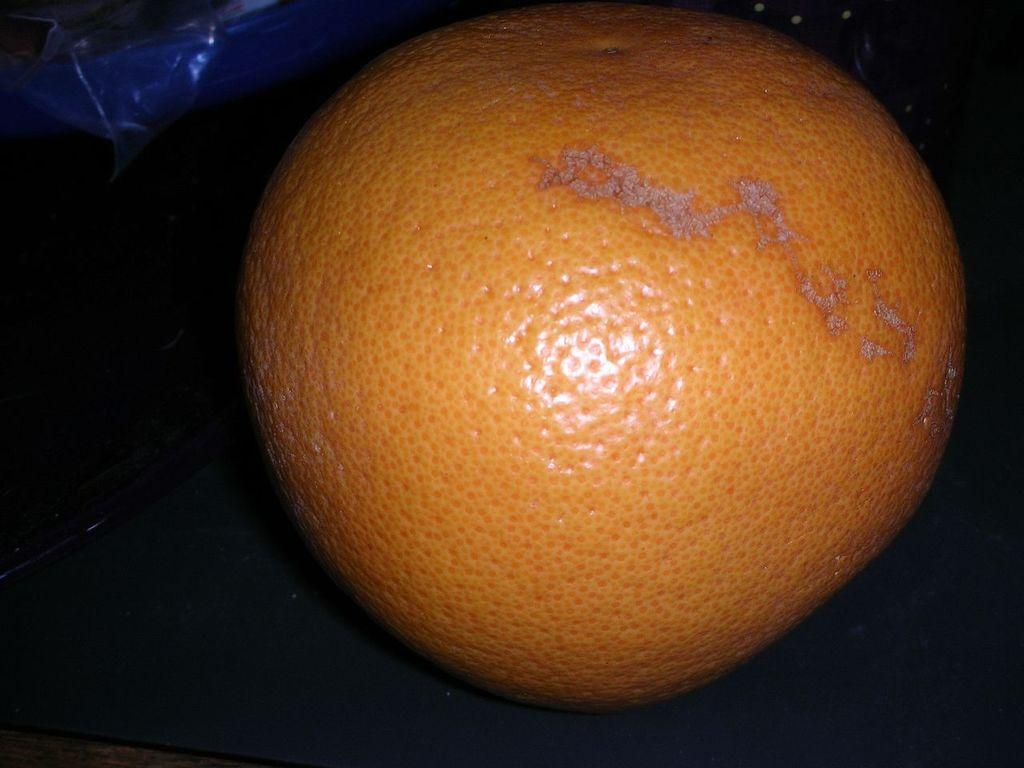What type of fruit is present in the image? There is an orange in the image. What object is located beside the orange? There is a cover beside the orange. Is there a baby sleeping under the orange in the image? No, there is no baby present in the image. 